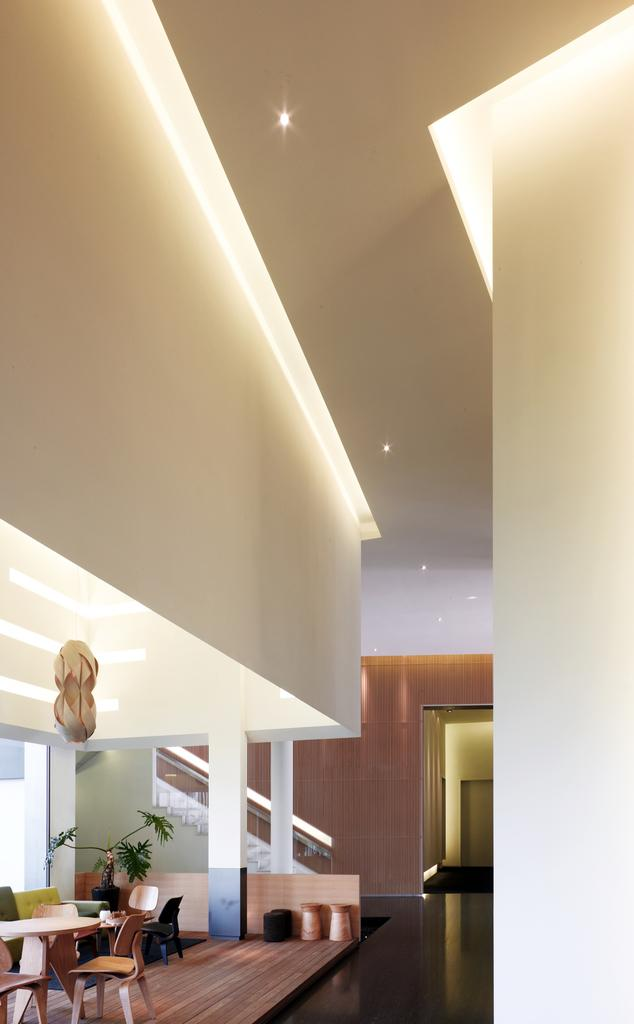What type of furniture can be seen in the image? There are chairs and tables in the image. What part of the room is visible in the image? The floor is visible in the image. Are there any plants in the image? Yes, there is a house plant in the image. What can be seen in the background of the image? There is a wall and steps in the background of the image. What is visible at the top of the image? Lights are visible at the top of the image. How many giants are visible in the image? There are no giants present in the image. What type of cattle can be seen grazing in the background of the image? There is no cattle present in the image; it features a wall and steps in the background. 